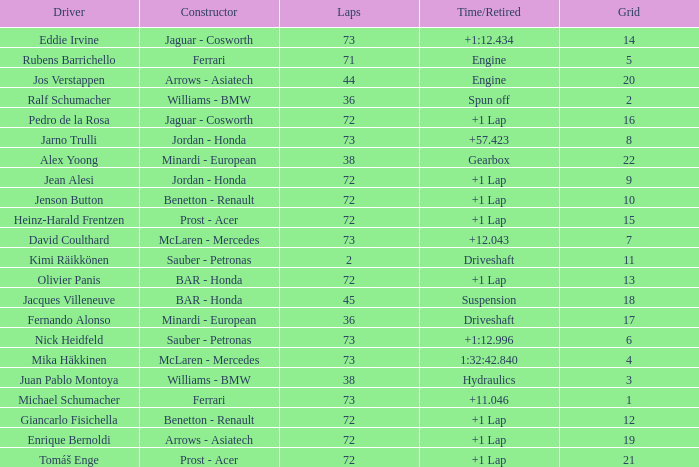Who is the constructor when the laps is more than 72 and the driver is eddie irvine? Jaguar - Cosworth. 